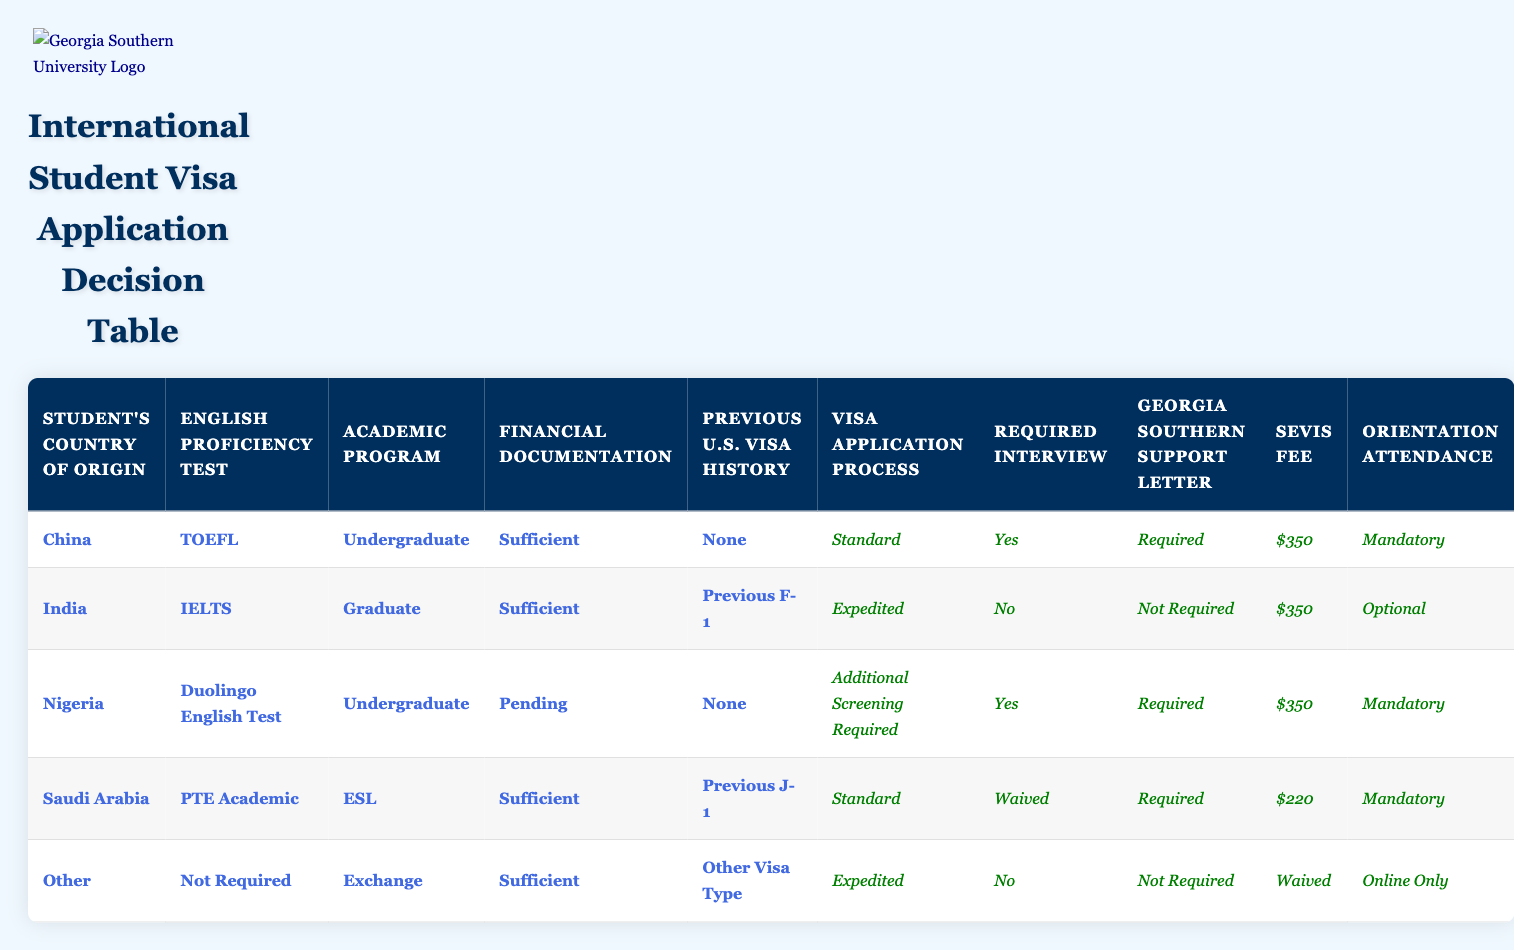What visa application process is required for a student from China with a TOEFL score? According to the table, for a student from China who has taken the TOEFL and is applying for an undergraduate program with sufficient financial documentation and no previous U.S. visa history, the visa application process is "Standard."
Answer: Standard Is an interview required for students from India with an IELTS if they have a previous F-1 visa? The table indicates that for students from India who present an IELTS score, are enrolled in a graduate program, have sufficient financial documentation, and have a previous F-1 visa, the required interview is "No."
Answer: No How many countries listed require a Georgia Southern support letter for their visa application process? Reviewing the table, the countries that require a Georgia Southern support letter are China, Nigeria, and Saudi Arabia. Counting these indicates there are three countries that require the letter.
Answer: 3 What is the SEVIS fee for a Saudi Arabian student applying for an ESL program? From the table, the SEVIS fee for a student from Saudi Arabia applying for an ESL program, having sufficient financial documentation and a previous J-1 visa is $220.
Answer: $220 Do students from Nigeria require an interview if their financial documentation is pending? The table shows that students from Nigeria with a pending financial documentation status require an interview, evidenced by the fact that their application is classified as needing "Additional Screening Required," which includes a "Yes" for the interview.
Answer: Yes If an international student from "Other" countries is applying as an exchange student with sufficient funds, what type of visa application process do they have? For students from "Other" countries applying as exchange students with sufficient financial documentation, the visa application process is categorized as "Expedited." This is determined by matching the specific conditions in the table.
Answer: Expedited What is the average SEVIS fee for the countries listed? The SEVIS fees indicated in the table are $350, $350, $350, $220, and Waived (which we can consider as $0 for the purpose of calculating the average). Adding these fees results in a total of $350 + $350 + $350 + $220 + 0 = $1,270. The average is thus $1,270 divided by 5, which is $254.
Answer: $254 Which academic program has the highest likelihood of requiring additional screening according to the table? Analyzing the table, the only program listed that requires additional screening is for a student from Nigeria applying for an undergraduate degree. This indicates that this is the only program mentioned that necessitates additional steps in the process.
Answer: Undergraduate What conditions do students from Nigeria face regarding their visa application process? Students from Nigeria applying for an undergraduate program with a pending financial documentation status face "Additional Screening Required," which also means they must attend an interview, receive a support letter, and incur a SEVIS fee of $350.
Answer: Additional Screening Required 